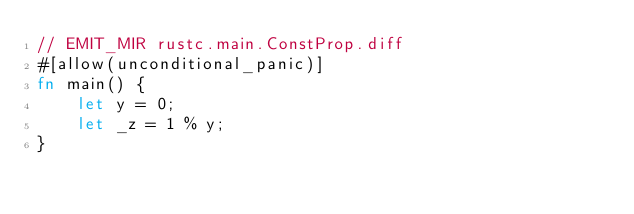<code> <loc_0><loc_0><loc_500><loc_500><_Rust_>// EMIT_MIR rustc.main.ConstProp.diff
#[allow(unconditional_panic)]
fn main() {
    let y = 0;
    let _z = 1 % y;
}
</code> 